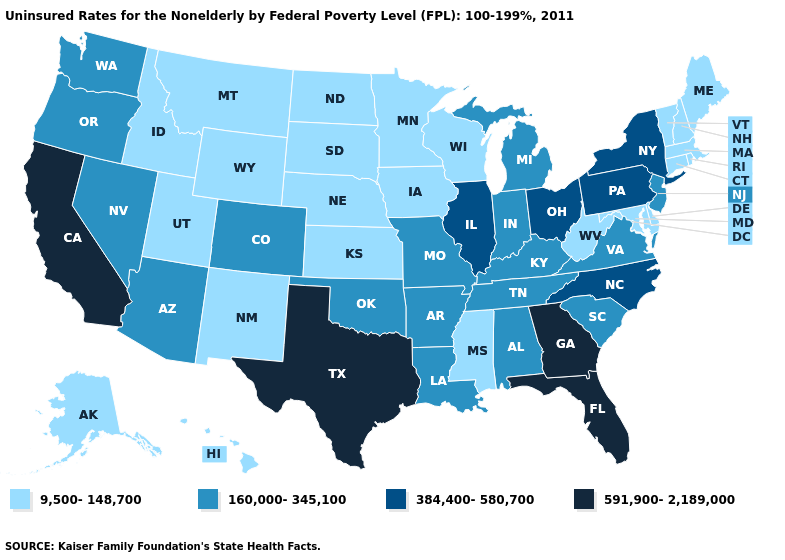Name the states that have a value in the range 160,000-345,100?
Answer briefly. Alabama, Arizona, Arkansas, Colorado, Indiana, Kentucky, Louisiana, Michigan, Missouri, Nevada, New Jersey, Oklahoma, Oregon, South Carolina, Tennessee, Virginia, Washington. Does Texas have a higher value than Minnesota?
Give a very brief answer. Yes. Among the states that border Wyoming , does Colorado have the lowest value?
Quick response, please. No. Name the states that have a value in the range 160,000-345,100?
Keep it brief. Alabama, Arizona, Arkansas, Colorado, Indiana, Kentucky, Louisiana, Michigan, Missouri, Nevada, New Jersey, Oklahoma, Oregon, South Carolina, Tennessee, Virginia, Washington. Does the map have missing data?
Be succinct. No. Which states hav the highest value in the Northeast?
Write a very short answer. New York, Pennsylvania. Name the states that have a value in the range 9,500-148,700?
Give a very brief answer. Alaska, Connecticut, Delaware, Hawaii, Idaho, Iowa, Kansas, Maine, Maryland, Massachusetts, Minnesota, Mississippi, Montana, Nebraska, New Hampshire, New Mexico, North Dakota, Rhode Island, South Dakota, Utah, Vermont, West Virginia, Wisconsin, Wyoming. Does Maine have the highest value in the Northeast?
Quick response, please. No. Does Alabama have the same value as Kentucky?
Write a very short answer. Yes. What is the value of Hawaii?
Keep it brief. 9,500-148,700. Does the first symbol in the legend represent the smallest category?
Keep it brief. Yes. Which states hav the highest value in the Northeast?
Write a very short answer. New York, Pennsylvania. What is the value of Oregon?
Short answer required. 160,000-345,100. Name the states that have a value in the range 160,000-345,100?
Keep it brief. Alabama, Arizona, Arkansas, Colorado, Indiana, Kentucky, Louisiana, Michigan, Missouri, Nevada, New Jersey, Oklahoma, Oregon, South Carolina, Tennessee, Virginia, Washington. Which states have the lowest value in the Northeast?
Short answer required. Connecticut, Maine, Massachusetts, New Hampshire, Rhode Island, Vermont. 